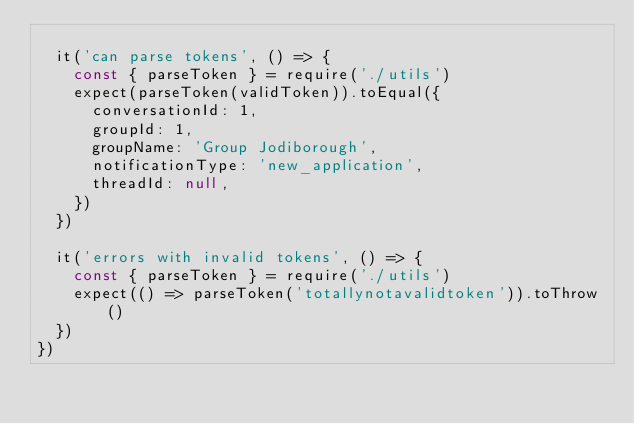Convert code to text. <code><loc_0><loc_0><loc_500><loc_500><_JavaScript_>
  it('can parse tokens', () => {
    const { parseToken } = require('./utils')
    expect(parseToken(validToken)).toEqual({
      conversationId: 1,
      groupId: 1,
      groupName: 'Group Jodiborough',
      notificationType: 'new_application',
      threadId: null,
    })
  })

  it('errors with invalid tokens', () => {
    const { parseToken } = require('./utils')
    expect(() => parseToken('totallynotavalidtoken')).toThrow()
  })
})
</code> 